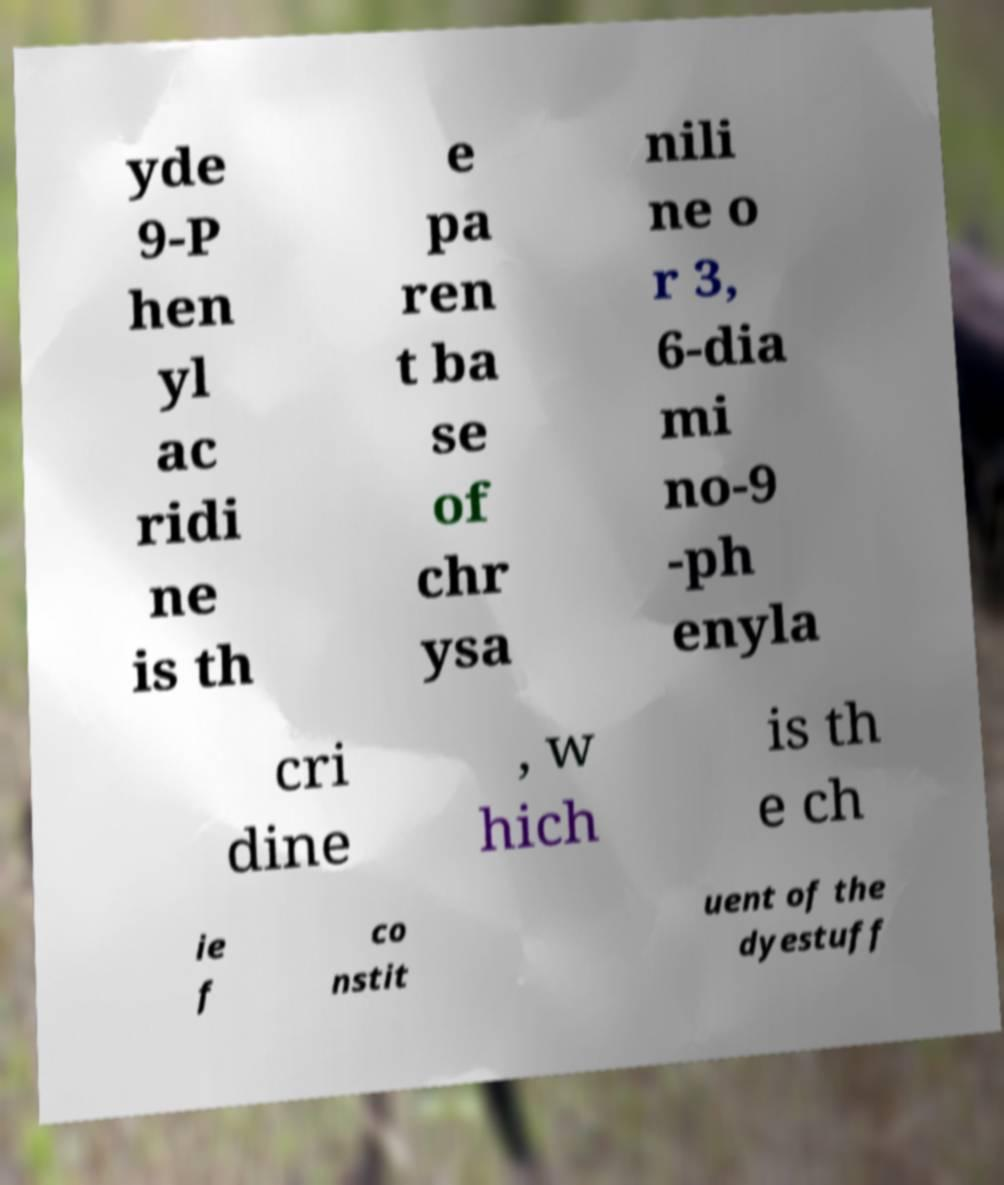Could you assist in decoding the text presented in this image and type it out clearly? yde 9-P hen yl ac ridi ne is th e pa ren t ba se of chr ysa nili ne o r 3, 6-dia mi no-9 -ph enyla cri dine , w hich is th e ch ie f co nstit uent of the dyestuff 